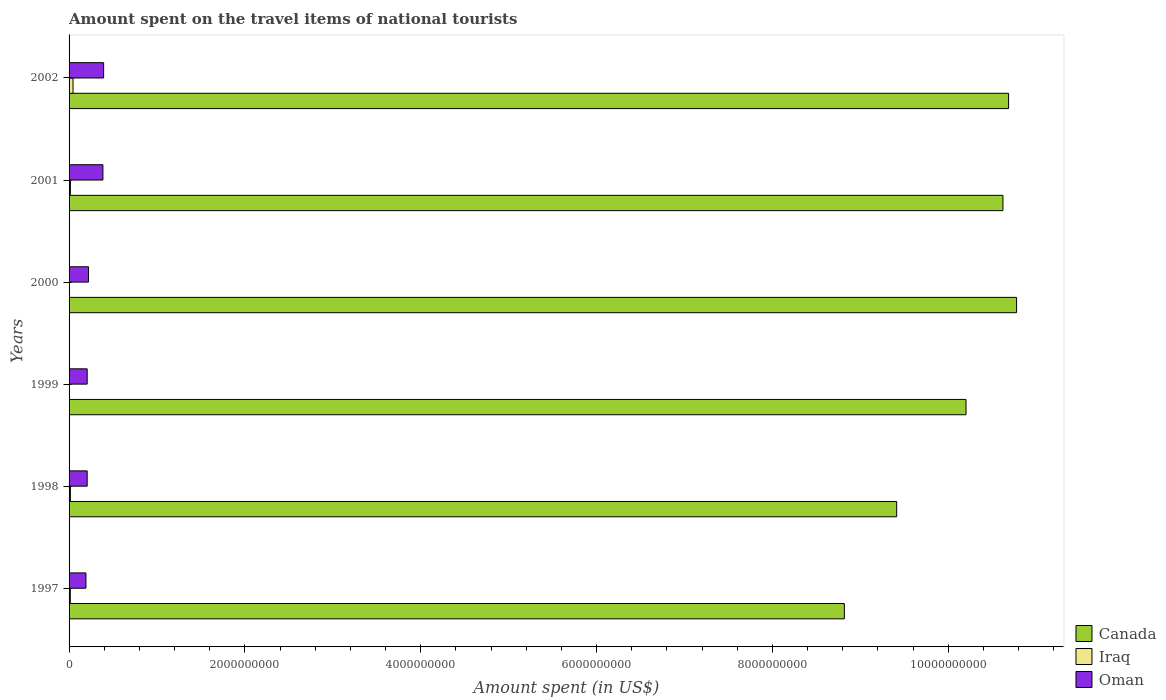How many groups of bars are there?
Offer a terse response. 6. Are the number of bars per tick equal to the number of legend labels?
Your response must be concise. Yes. How many bars are there on the 2nd tick from the top?
Your answer should be compact. 3. How many bars are there on the 6th tick from the bottom?
Make the answer very short. 3. In how many cases, is the number of bars for a given year not equal to the number of legend labels?
Offer a terse response. 0. What is the amount spent on the travel items of national tourists in Oman in 1999?
Give a very brief answer. 2.06e+08. Across all years, what is the maximum amount spent on the travel items of national tourists in Oman?
Offer a very short reply. 3.93e+08. Across all years, what is the minimum amount spent on the travel items of national tourists in Oman?
Ensure brevity in your answer.  1.92e+08. What is the total amount spent on the travel items of national tourists in Canada in the graph?
Provide a short and direct response. 6.05e+1. What is the difference between the amount spent on the travel items of national tourists in Canada in 1997 and that in 2000?
Offer a terse response. -1.96e+09. What is the difference between the amount spent on the travel items of national tourists in Canada in 1998 and the amount spent on the travel items of national tourists in Iraq in 2001?
Your response must be concise. 9.40e+09. What is the average amount spent on the travel items of national tourists in Canada per year?
Your answer should be very brief. 1.01e+1. In the year 2002, what is the difference between the amount spent on the travel items of national tourists in Oman and amount spent on the travel items of national tourists in Canada?
Make the answer very short. -1.03e+1. In how many years, is the amount spent on the travel items of national tourists in Oman greater than 9600000000 US$?
Make the answer very short. 0. What is the ratio of the amount spent on the travel items of national tourists in Oman in 1998 to that in 2000?
Give a very brief answer. 0.93. Is the amount spent on the travel items of national tourists in Canada in 2001 less than that in 2002?
Ensure brevity in your answer.  Yes. What is the difference between the highest and the second highest amount spent on the travel items of national tourists in Canada?
Make the answer very short. 9.10e+07. What is the difference between the highest and the lowest amount spent on the travel items of national tourists in Iraq?
Your answer should be compact. 4.40e+07. In how many years, is the amount spent on the travel items of national tourists in Oman greater than the average amount spent on the travel items of national tourists in Oman taken over all years?
Your answer should be compact. 2. Is the sum of the amount spent on the travel items of national tourists in Iraq in 1998 and 2002 greater than the maximum amount spent on the travel items of national tourists in Oman across all years?
Offer a very short reply. No. What does the 3rd bar from the bottom in 2000 represents?
Offer a terse response. Oman. Is it the case that in every year, the sum of the amount spent on the travel items of national tourists in Iraq and amount spent on the travel items of national tourists in Oman is greater than the amount spent on the travel items of national tourists in Canada?
Make the answer very short. No. What is the difference between two consecutive major ticks on the X-axis?
Your answer should be very brief. 2.00e+09. Does the graph contain any zero values?
Provide a short and direct response. No. Does the graph contain grids?
Provide a succinct answer. No. Where does the legend appear in the graph?
Your answer should be very brief. Bottom right. How many legend labels are there?
Make the answer very short. 3. How are the legend labels stacked?
Make the answer very short. Vertical. What is the title of the graph?
Your answer should be compact. Amount spent on the travel items of national tourists. Does "Bermuda" appear as one of the legend labels in the graph?
Your answer should be very brief. No. What is the label or title of the X-axis?
Your response must be concise. Amount spent (in US$). What is the label or title of the Y-axis?
Provide a short and direct response. Years. What is the Amount spent (in US$) in Canada in 1997?
Ensure brevity in your answer.  8.82e+09. What is the Amount spent (in US$) in Iraq in 1997?
Your response must be concise. 1.40e+07. What is the Amount spent (in US$) in Oman in 1997?
Offer a terse response. 1.92e+08. What is the Amount spent (in US$) in Canada in 1998?
Your response must be concise. 9.41e+09. What is the Amount spent (in US$) of Iraq in 1998?
Your answer should be compact. 1.50e+07. What is the Amount spent (in US$) of Oman in 1998?
Ensure brevity in your answer.  2.06e+08. What is the Amount spent (in US$) of Canada in 1999?
Make the answer very short. 1.02e+1. What is the Amount spent (in US$) of Oman in 1999?
Ensure brevity in your answer.  2.06e+08. What is the Amount spent (in US$) in Canada in 2000?
Offer a very short reply. 1.08e+1. What is the Amount spent (in US$) in Iraq in 2000?
Provide a short and direct response. 2.00e+06. What is the Amount spent (in US$) of Oman in 2000?
Provide a short and direct response. 2.21e+08. What is the Amount spent (in US$) of Canada in 2001?
Your answer should be compact. 1.06e+1. What is the Amount spent (in US$) of Iraq in 2001?
Offer a very short reply. 1.50e+07. What is the Amount spent (in US$) of Oman in 2001?
Provide a succinct answer. 3.85e+08. What is the Amount spent (in US$) in Canada in 2002?
Your answer should be very brief. 1.07e+1. What is the Amount spent (in US$) in Iraq in 2002?
Your response must be concise. 4.50e+07. What is the Amount spent (in US$) of Oman in 2002?
Ensure brevity in your answer.  3.93e+08. Across all years, what is the maximum Amount spent (in US$) in Canada?
Your response must be concise. 1.08e+1. Across all years, what is the maximum Amount spent (in US$) in Iraq?
Your response must be concise. 4.50e+07. Across all years, what is the maximum Amount spent (in US$) in Oman?
Make the answer very short. 3.93e+08. Across all years, what is the minimum Amount spent (in US$) in Canada?
Keep it short and to the point. 8.82e+09. Across all years, what is the minimum Amount spent (in US$) of Iraq?
Give a very brief answer. 1.00e+06. Across all years, what is the minimum Amount spent (in US$) of Oman?
Give a very brief answer. 1.92e+08. What is the total Amount spent (in US$) in Canada in the graph?
Offer a terse response. 6.05e+1. What is the total Amount spent (in US$) of Iraq in the graph?
Offer a very short reply. 9.20e+07. What is the total Amount spent (in US$) of Oman in the graph?
Provide a short and direct response. 1.60e+09. What is the difference between the Amount spent (in US$) of Canada in 1997 and that in 1998?
Make the answer very short. -5.95e+08. What is the difference between the Amount spent (in US$) of Iraq in 1997 and that in 1998?
Your answer should be very brief. -1.00e+06. What is the difference between the Amount spent (in US$) in Oman in 1997 and that in 1998?
Offer a very short reply. -1.40e+07. What is the difference between the Amount spent (in US$) in Canada in 1997 and that in 1999?
Your response must be concise. -1.38e+09. What is the difference between the Amount spent (in US$) of Iraq in 1997 and that in 1999?
Offer a very short reply. 1.30e+07. What is the difference between the Amount spent (in US$) in Oman in 1997 and that in 1999?
Offer a very short reply. -1.40e+07. What is the difference between the Amount spent (in US$) in Canada in 1997 and that in 2000?
Keep it short and to the point. -1.96e+09. What is the difference between the Amount spent (in US$) of Iraq in 1997 and that in 2000?
Your answer should be very brief. 1.20e+07. What is the difference between the Amount spent (in US$) of Oman in 1997 and that in 2000?
Make the answer very short. -2.90e+07. What is the difference between the Amount spent (in US$) of Canada in 1997 and that in 2001?
Your answer should be very brief. -1.80e+09. What is the difference between the Amount spent (in US$) of Oman in 1997 and that in 2001?
Your answer should be compact. -1.93e+08. What is the difference between the Amount spent (in US$) of Canada in 1997 and that in 2002?
Make the answer very short. -1.87e+09. What is the difference between the Amount spent (in US$) in Iraq in 1997 and that in 2002?
Give a very brief answer. -3.10e+07. What is the difference between the Amount spent (in US$) of Oman in 1997 and that in 2002?
Provide a succinct answer. -2.01e+08. What is the difference between the Amount spent (in US$) of Canada in 1998 and that in 1999?
Give a very brief answer. -7.89e+08. What is the difference between the Amount spent (in US$) in Iraq in 1998 and that in 1999?
Your response must be concise. 1.40e+07. What is the difference between the Amount spent (in US$) of Canada in 1998 and that in 2000?
Give a very brief answer. -1.36e+09. What is the difference between the Amount spent (in US$) in Iraq in 1998 and that in 2000?
Provide a succinct answer. 1.30e+07. What is the difference between the Amount spent (in US$) of Oman in 1998 and that in 2000?
Make the answer very short. -1.50e+07. What is the difference between the Amount spent (in US$) of Canada in 1998 and that in 2001?
Your answer should be very brief. -1.21e+09. What is the difference between the Amount spent (in US$) of Iraq in 1998 and that in 2001?
Your answer should be compact. 0. What is the difference between the Amount spent (in US$) in Oman in 1998 and that in 2001?
Your answer should be compact. -1.79e+08. What is the difference between the Amount spent (in US$) in Canada in 1998 and that in 2002?
Give a very brief answer. -1.27e+09. What is the difference between the Amount spent (in US$) in Iraq in 1998 and that in 2002?
Ensure brevity in your answer.  -3.00e+07. What is the difference between the Amount spent (in US$) of Oman in 1998 and that in 2002?
Offer a terse response. -1.87e+08. What is the difference between the Amount spent (in US$) of Canada in 1999 and that in 2000?
Provide a short and direct response. -5.75e+08. What is the difference between the Amount spent (in US$) in Oman in 1999 and that in 2000?
Your answer should be very brief. -1.50e+07. What is the difference between the Amount spent (in US$) of Canada in 1999 and that in 2001?
Your answer should be compact. -4.20e+08. What is the difference between the Amount spent (in US$) in Iraq in 1999 and that in 2001?
Ensure brevity in your answer.  -1.40e+07. What is the difference between the Amount spent (in US$) in Oman in 1999 and that in 2001?
Your response must be concise. -1.79e+08. What is the difference between the Amount spent (in US$) of Canada in 1999 and that in 2002?
Ensure brevity in your answer.  -4.84e+08. What is the difference between the Amount spent (in US$) in Iraq in 1999 and that in 2002?
Offer a very short reply. -4.40e+07. What is the difference between the Amount spent (in US$) in Oman in 1999 and that in 2002?
Offer a very short reply. -1.87e+08. What is the difference between the Amount spent (in US$) in Canada in 2000 and that in 2001?
Provide a succinct answer. 1.55e+08. What is the difference between the Amount spent (in US$) of Iraq in 2000 and that in 2001?
Your answer should be very brief. -1.30e+07. What is the difference between the Amount spent (in US$) of Oman in 2000 and that in 2001?
Give a very brief answer. -1.64e+08. What is the difference between the Amount spent (in US$) of Canada in 2000 and that in 2002?
Offer a very short reply. 9.10e+07. What is the difference between the Amount spent (in US$) of Iraq in 2000 and that in 2002?
Your answer should be very brief. -4.30e+07. What is the difference between the Amount spent (in US$) of Oman in 2000 and that in 2002?
Your answer should be compact. -1.72e+08. What is the difference between the Amount spent (in US$) of Canada in 2001 and that in 2002?
Offer a terse response. -6.40e+07. What is the difference between the Amount spent (in US$) in Iraq in 2001 and that in 2002?
Offer a very short reply. -3.00e+07. What is the difference between the Amount spent (in US$) of Oman in 2001 and that in 2002?
Provide a short and direct response. -8.00e+06. What is the difference between the Amount spent (in US$) in Canada in 1997 and the Amount spent (in US$) in Iraq in 1998?
Offer a terse response. 8.80e+09. What is the difference between the Amount spent (in US$) in Canada in 1997 and the Amount spent (in US$) in Oman in 1998?
Provide a succinct answer. 8.61e+09. What is the difference between the Amount spent (in US$) of Iraq in 1997 and the Amount spent (in US$) of Oman in 1998?
Your answer should be compact. -1.92e+08. What is the difference between the Amount spent (in US$) of Canada in 1997 and the Amount spent (in US$) of Iraq in 1999?
Your response must be concise. 8.82e+09. What is the difference between the Amount spent (in US$) in Canada in 1997 and the Amount spent (in US$) in Oman in 1999?
Give a very brief answer. 8.61e+09. What is the difference between the Amount spent (in US$) of Iraq in 1997 and the Amount spent (in US$) of Oman in 1999?
Offer a very short reply. -1.92e+08. What is the difference between the Amount spent (in US$) in Canada in 1997 and the Amount spent (in US$) in Iraq in 2000?
Offer a terse response. 8.82e+09. What is the difference between the Amount spent (in US$) in Canada in 1997 and the Amount spent (in US$) in Oman in 2000?
Your answer should be very brief. 8.60e+09. What is the difference between the Amount spent (in US$) of Iraq in 1997 and the Amount spent (in US$) of Oman in 2000?
Your answer should be compact. -2.07e+08. What is the difference between the Amount spent (in US$) in Canada in 1997 and the Amount spent (in US$) in Iraq in 2001?
Your response must be concise. 8.80e+09. What is the difference between the Amount spent (in US$) of Canada in 1997 and the Amount spent (in US$) of Oman in 2001?
Your response must be concise. 8.43e+09. What is the difference between the Amount spent (in US$) in Iraq in 1997 and the Amount spent (in US$) in Oman in 2001?
Provide a short and direct response. -3.71e+08. What is the difference between the Amount spent (in US$) in Canada in 1997 and the Amount spent (in US$) in Iraq in 2002?
Ensure brevity in your answer.  8.77e+09. What is the difference between the Amount spent (in US$) in Canada in 1997 and the Amount spent (in US$) in Oman in 2002?
Ensure brevity in your answer.  8.43e+09. What is the difference between the Amount spent (in US$) in Iraq in 1997 and the Amount spent (in US$) in Oman in 2002?
Provide a succinct answer. -3.79e+08. What is the difference between the Amount spent (in US$) of Canada in 1998 and the Amount spent (in US$) of Iraq in 1999?
Ensure brevity in your answer.  9.41e+09. What is the difference between the Amount spent (in US$) in Canada in 1998 and the Amount spent (in US$) in Oman in 1999?
Provide a short and direct response. 9.21e+09. What is the difference between the Amount spent (in US$) in Iraq in 1998 and the Amount spent (in US$) in Oman in 1999?
Your answer should be compact. -1.91e+08. What is the difference between the Amount spent (in US$) in Canada in 1998 and the Amount spent (in US$) in Iraq in 2000?
Give a very brief answer. 9.41e+09. What is the difference between the Amount spent (in US$) in Canada in 1998 and the Amount spent (in US$) in Oman in 2000?
Provide a succinct answer. 9.19e+09. What is the difference between the Amount spent (in US$) in Iraq in 1998 and the Amount spent (in US$) in Oman in 2000?
Provide a succinct answer. -2.06e+08. What is the difference between the Amount spent (in US$) of Canada in 1998 and the Amount spent (in US$) of Iraq in 2001?
Provide a short and direct response. 9.40e+09. What is the difference between the Amount spent (in US$) in Canada in 1998 and the Amount spent (in US$) in Oman in 2001?
Your response must be concise. 9.03e+09. What is the difference between the Amount spent (in US$) in Iraq in 1998 and the Amount spent (in US$) in Oman in 2001?
Your answer should be compact. -3.70e+08. What is the difference between the Amount spent (in US$) in Canada in 1998 and the Amount spent (in US$) in Iraq in 2002?
Provide a short and direct response. 9.37e+09. What is the difference between the Amount spent (in US$) in Canada in 1998 and the Amount spent (in US$) in Oman in 2002?
Make the answer very short. 9.02e+09. What is the difference between the Amount spent (in US$) in Iraq in 1998 and the Amount spent (in US$) in Oman in 2002?
Make the answer very short. -3.78e+08. What is the difference between the Amount spent (in US$) in Canada in 1999 and the Amount spent (in US$) in Iraq in 2000?
Provide a short and direct response. 1.02e+1. What is the difference between the Amount spent (in US$) in Canada in 1999 and the Amount spent (in US$) in Oman in 2000?
Give a very brief answer. 9.98e+09. What is the difference between the Amount spent (in US$) of Iraq in 1999 and the Amount spent (in US$) of Oman in 2000?
Ensure brevity in your answer.  -2.20e+08. What is the difference between the Amount spent (in US$) in Canada in 1999 and the Amount spent (in US$) in Iraq in 2001?
Offer a very short reply. 1.02e+1. What is the difference between the Amount spent (in US$) in Canada in 1999 and the Amount spent (in US$) in Oman in 2001?
Offer a terse response. 9.82e+09. What is the difference between the Amount spent (in US$) in Iraq in 1999 and the Amount spent (in US$) in Oman in 2001?
Your answer should be compact. -3.84e+08. What is the difference between the Amount spent (in US$) of Canada in 1999 and the Amount spent (in US$) of Iraq in 2002?
Provide a succinct answer. 1.02e+1. What is the difference between the Amount spent (in US$) in Canada in 1999 and the Amount spent (in US$) in Oman in 2002?
Offer a very short reply. 9.81e+09. What is the difference between the Amount spent (in US$) of Iraq in 1999 and the Amount spent (in US$) of Oman in 2002?
Give a very brief answer. -3.92e+08. What is the difference between the Amount spent (in US$) in Canada in 2000 and the Amount spent (in US$) in Iraq in 2001?
Provide a short and direct response. 1.08e+1. What is the difference between the Amount spent (in US$) in Canada in 2000 and the Amount spent (in US$) in Oman in 2001?
Provide a short and direct response. 1.04e+1. What is the difference between the Amount spent (in US$) in Iraq in 2000 and the Amount spent (in US$) in Oman in 2001?
Offer a very short reply. -3.83e+08. What is the difference between the Amount spent (in US$) in Canada in 2000 and the Amount spent (in US$) in Iraq in 2002?
Provide a succinct answer. 1.07e+1. What is the difference between the Amount spent (in US$) in Canada in 2000 and the Amount spent (in US$) in Oman in 2002?
Ensure brevity in your answer.  1.04e+1. What is the difference between the Amount spent (in US$) in Iraq in 2000 and the Amount spent (in US$) in Oman in 2002?
Give a very brief answer. -3.91e+08. What is the difference between the Amount spent (in US$) of Canada in 2001 and the Amount spent (in US$) of Iraq in 2002?
Make the answer very short. 1.06e+1. What is the difference between the Amount spent (in US$) in Canada in 2001 and the Amount spent (in US$) in Oman in 2002?
Provide a short and direct response. 1.02e+1. What is the difference between the Amount spent (in US$) in Iraq in 2001 and the Amount spent (in US$) in Oman in 2002?
Keep it short and to the point. -3.78e+08. What is the average Amount spent (in US$) in Canada per year?
Offer a terse response. 1.01e+1. What is the average Amount spent (in US$) of Iraq per year?
Keep it short and to the point. 1.53e+07. What is the average Amount spent (in US$) in Oman per year?
Your response must be concise. 2.67e+08. In the year 1997, what is the difference between the Amount spent (in US$) of Canada and Amount spent (in US$) of Iraq?
Ensure brevity in your answer.  8.80e+09. In the year 1997, what is the difference between the Amount spent (in US$) of Canada and Amount spent (in US$) of Oman?
Offer a terse response. 8.63e+09. In the year 1997, what is the difference between the Amount spent (in US$) of Iraq and Amount spent (in US$) of Oman?
Provide a short and direct response. -1.78e+08. In the year 1998, what is the difference between the Amount spent (in US$) of Canada and Amount spent (in US$) of Iraq?
Offer a very short reply. 9.40e+09. In the year 1998, what is the difference between the Amount spent (in US$) of Canada and Amount spent (in US$) of Oman?
Ensure brevity in your answer.  9.21e+09. In the year 1998, what is the difference between the Amount spent (in US$) of Iraq and Amount spent (in US$) of Oman?
Your response must be concise. -1.91e+08. In the year 1999, what is the difference between the Amount spent (in US$) in Canada and Amount spent (in US$) in Iraq?
Offer a terse response. 1.02e+1. In the year 1999, what is the difference between the Amount spent (in US$) in Canada and Amount spent (in US$) in Oman?
Your response must be concise. 1.00e+1. In the year 1999, what is the difference between the Amount spent (in US$) of Iraq and Amount spent (in US$) of Oman?
Provide a short and direct response. -2.05e+08. In the year 2000, what is the difference between the Amount spent (in US$) in Canada and Amount spent (in US$) in Iraq?
Your response must be concise. 1.08e+1. In the year 2000, what is the difference between the Amount spent (in US$) of Canada and Amount spent (in US$) of Oman?
Keep it short and to the point. 1.06e+1. In the year 2000, what is the difference between the Amount spent (in US$) in Iraq and Amount spent (in US$) in Oman?
Your answer should be compact. -2.19e+08. In the year 2001, what is the difference between the Amount spent (in US$) in Canada and Amount spent (in US$) in Iraq?
Offer a very short reply. 1.06e+1. In the year 2001, what is the difference between the Amount spent (in US$) in Canada and Amount spent (in US$) in Oman?
Ensure brevity in your answer.  1.02e+1. In the year 2001, what is the difference between the Amount spent (in US$) in Iraq and Amount spent (in US$) in Oman?
Offer a terse response. -3.70e+08. In the year 2002, what is the difference between the Amount spent (in US$) of Canada and Amount spent (in US$) of Iraq?
Your answer should be very brief. 1.06e+1. In the year 2002, what is the difference between the Amount spent (in US$) of Canada and Amount spent (in US$) of Oman?
Your answer should be very brief. 1.03e+1. In the year 2002, what is the difference between the Amount spent (in US$) in Iraq and Amount spent (in US$) in Oman?
Keep it short and to the point. -3.48e+08. What is the ratio of the Amount spent (in US$) of Canada in 1997 to that in 1998?
Your response must be concise. 0.94. What is the ratio of the Amount spent (in US$) in Iraq in 1997 to that in 1998?
Keep it short and to the point. 0.93. What is the ratio of the Amount spent (in US$) of Oman in 1997 to that in 1998?
Provide a succinct answer. 0.93. What is the ratio of the Amount spent (in US$) of Canada in 1997 to that in 1999?
Your answer should be compact. 0.86. What is the ratio of the Amount spent (in US$) of Oman in 1997 to that in 1999?
Offer a terse response. 0.93. What is the ratio of the Amount spent (in US$) in Canada in 1997 to that in 2000?
Offer a terse response. 0.82. What is the ratio of the Amount spent (in US$) of Iraq in 1997 to that in 2000?
Ensure brevity in your answer.  7. What is the ratio of the Amount spent (in US$) in Oman in 1997 to that in 2000?
Your response must be concise. 0.87. What is the ratio of the Amount spent (in US$) in Canada in 1997 to that in 2001?
Ensure brevity in your answer.  0.83. What is the ratio of the Amount spent (in US$) in Iraq in 1997 to that in 2001?
Give a very brief answer. 0.93. What is the ratio of the Amount spent (in US$) in Oman in 1997 to that in 2001?
Give a very brief answer. 0.5. What is the ratio of the Amount spent (in US$) of Canada in 1997 to that in 2002?
Give a very brief answer. 0.83. What is the ratio of the Amount spent (in US$) in Iraq in 1997 to that in 2002?
Your answer should be very brief. 0.31. What is the ratio of the Amount spent (in US$) in Oman in 1997 to that in 2002?
Keep it short and to the point. 0.49. What is the ratio of the Amount spent (in US$) of Canada in 1998 to that in 1999?
Give a very brief answer. 0.92. What is the ratio of the Amount spent (in US$) in Iraq in 1998 to that in 1999?
Offer a terse response. 15. What is the ratio of the Amount spent (in US$) of Oman in 1998 to that in 1999?
Offer a terse response. 1. What is the ratio of the Amount spent (in US$) of Canada in 1998 to that in 2000?
Offer a terse response. 0.87. What is the ratio of the Amount spent (in US$) in Iraq in 1998 to that in 2000?
Your answer should be compact. 7.5. What is the ratio of the Amount spent (in US$) of Oman in 1998 to that in 2000?
Your response must be concise. 0.93. What is the ratio of the Amount spent (in US$) of Canada in 1998 to that in 2001?
Keep it short and to the point. 0.89. What is the ratio of the Amount spent (in US$) of Iraq in 1998 to that in 2001?
Make the answer very short. 1. What is the ratio of the Amount spent (in US$) of Oman in 1998 to that in 2001?
Your answer should be compact. 0.54. What is the ratio of the Amount spent (in US$) of Canada in 1998 to that in 2002?
Ensure brevity in your answer.  0.88. What is the ratio of the Amount spent (in US$) in Oman in 1998 to that in 2002?
Give a very brief answer. 0.52. What is the ratio of the Amount spent (in US$) of Canada in 1999 to that in 2000?
Ensure brevity in your answer.  0.95. What is the ratio of the Amount spent (in US$) of Oman in 1999 to that in 2000?
Your answer should be very brief. 0.93. What is the ratio of the Amount spent (in US$) of Canada in 1999 to that in 2001?
Provide a short and direct response. 0.96. What is the ratio of the Amount spent (in US$) of Iraq in 1999 to that in 2001?
Your answer should be compact. 0.07. What is the ratio of the Amount spent (in US$) of Oman in 1999 to that in 2001?
Keep it short and to the point. 0.54. What is the ratio of the Amount spent (in US$) in Canada in 1999 to that in 2002?
Your answer should be compact. 0.95. What is the ratio of the Amount spent (in US$) of Iraq in 1999 to that in 2002?
Your answer should be compact. 0.02. What is the ratio of the Amount spent (in US$) of Oman in 1999 to that in 2002?
Keep it short and to the point. 0.52. What is the ratio of the Amount spent (in US$) of Canada in 2000 to that in 2001?
Provide a succinct answer. 1.01. What is the ratio of the Amount spent (in US$) in Iraq in 2000 to that in 2001?
Offer a terse response. 0.13. What is the ratio of the Amount spent (in US$) in Oman in 2000 to that in 2001?
Your answer should be very brief. 0.57. What is the ratio of the Amount spent (in US$) of Canada in 2000 to that in 2002?
Provide a succinct answer. 1.01. What is the ratio of the Amount spent (in US$) in Iraq in 2000 to that in 2002?
Your answer should be very brief. 0.04. What is the ratio of the Amount spent (in US$) of Oman in 2000 to that in 2002?
Your answer should be compact. 0.56. What is the ratio of the Amount spent (in US$) of Canada in 2001 to that in 2002?
Offer a very short reply. 0.99. What is the ratio of the Amount spent (in US$) in Oman in 2001 to that in 2002?
Ensure brevity in your answer.  0.98. What is the difference between the highest and the second highest Amount spent (in US$) in Canada?
Give a very brief answer. 9.10e+07. What is the difference between the highest and the second highest Amount spent (in US$) of Iraq?
Make the answer very short. 3.00e+07. What is the difference between the highest and the second highest Amount spent (in US$) of Oman?
Provide a short and direct response. 8.00e+06. What is the difference between the highest and the lowest Amount spent (in US$) of Canada?
Keep it short and to the point. 1.96e+09. What is the difference between the highest and the lowest Amount spent (in US$) in Iraq?
Your answer should be very brief. 4.40e+07. What is the difference between the highest and the lowest Amount spent (in US$) in Oman?
Your answer should be compact. 2.01e+08. 